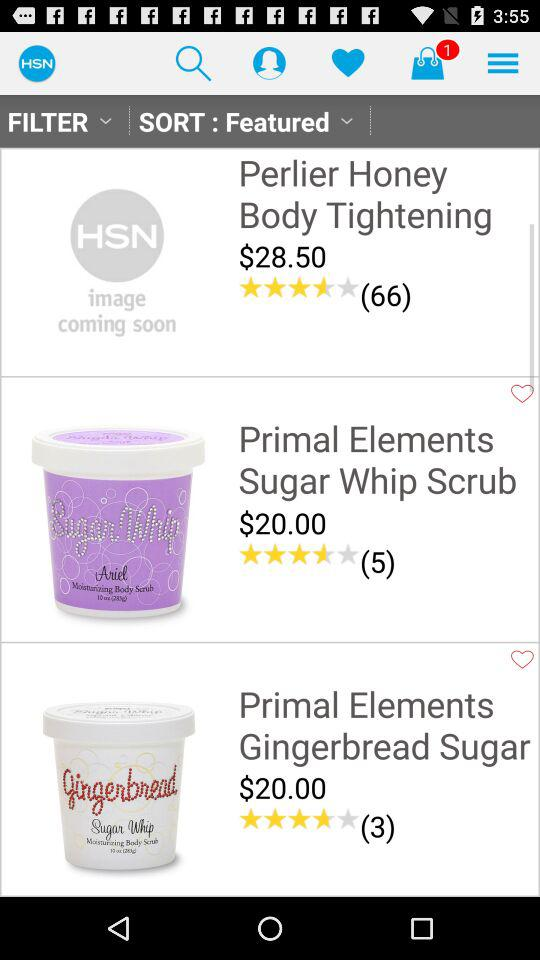What is the price of the "Perlier Honey Body Tightening"? The price of the "Perlier Honey Body Tightening" is $28.50. 